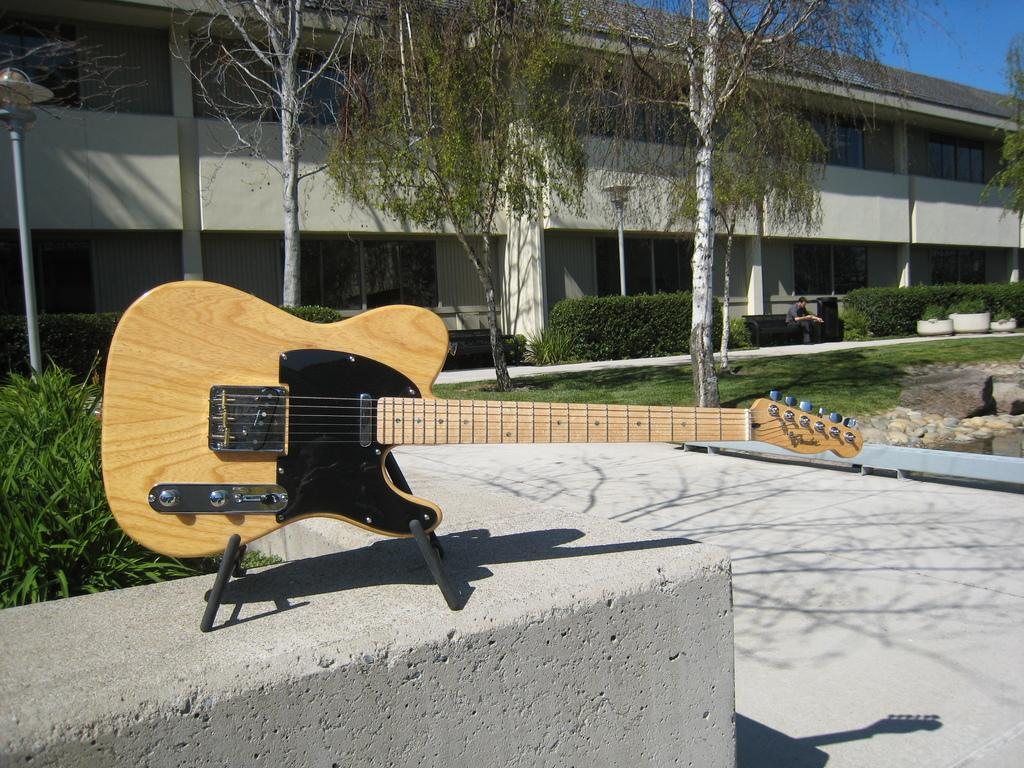What musical instrument is visible in the image? There is a guitar in the image. What type of vegetation can be seen in the image? There are plants and trees in the image. What can be seen in the background of the image? There is a building, trees, and a person sitting on a bench in the background of the image. What is visible in the sky in the image? The sky is visible in the background of the image. How many cans of paint are being used by the group in the image? There is no group or cans of paint present in the image. 